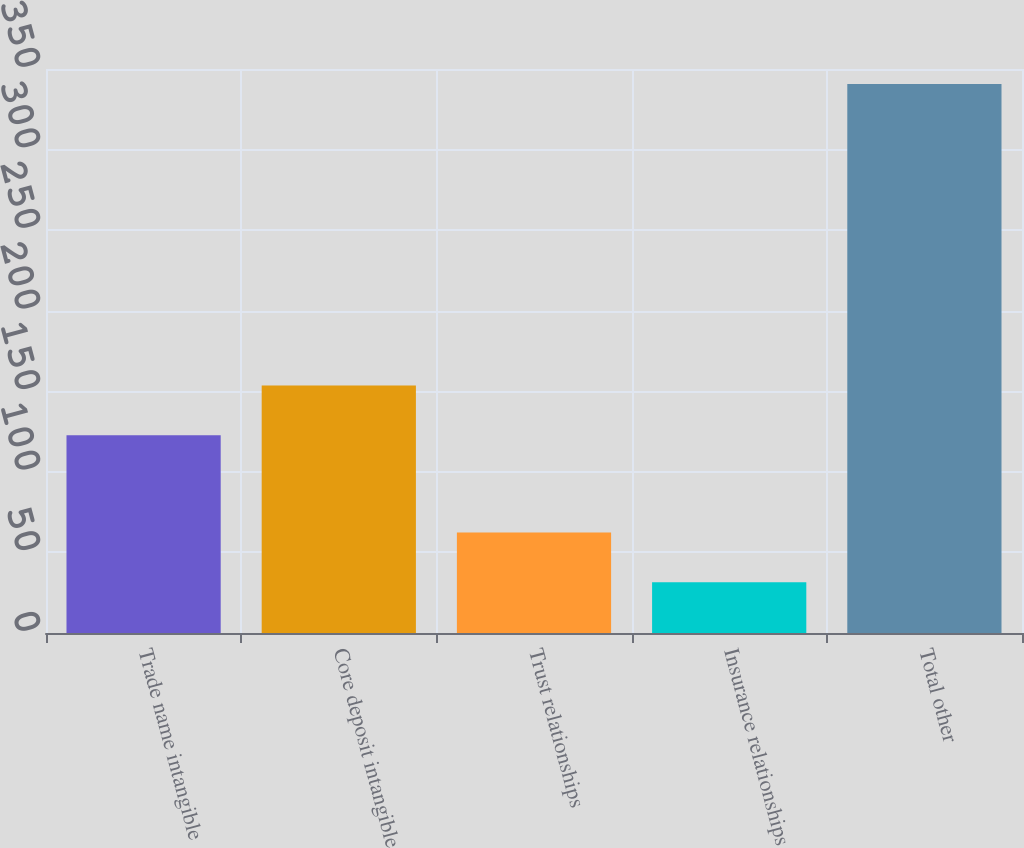Convert chart. <chart><loc_0><loc_0><loc_500><loc_500><bar_chart><fcel>Trade name intangible<fcel>Core deposit intangible<fcel>Trust relationships<fcel>Insurance relationships<fcel>Total other<nl><fcel>122.7<fcel>153.62<fcel>62.42<fcel>31.5<fcel>340.7<nl></chart> 